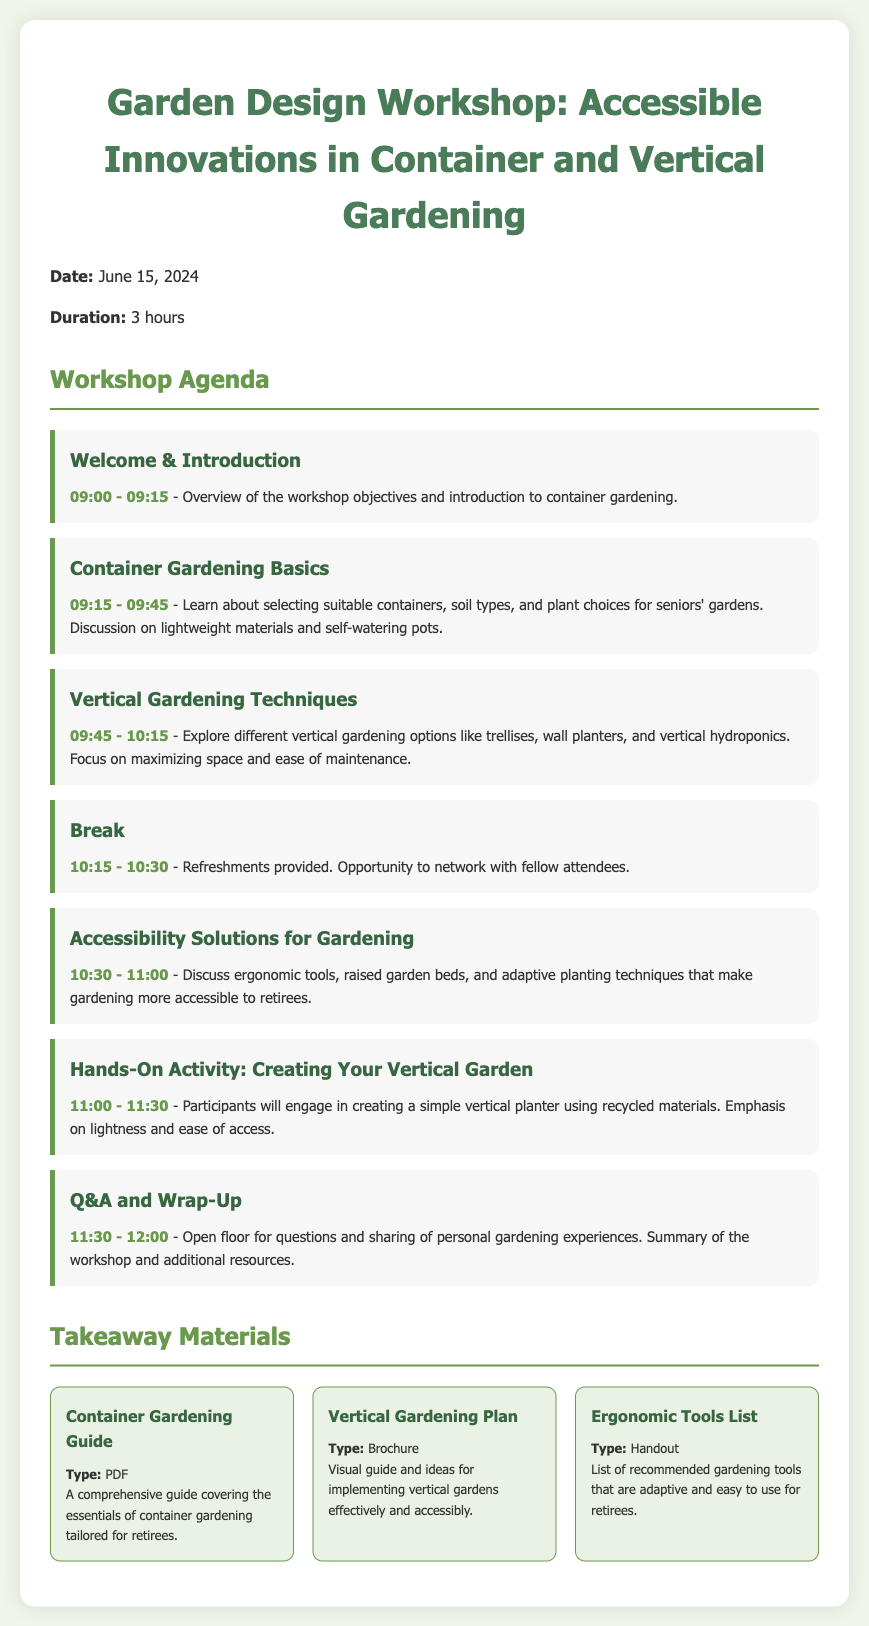What is the date of the workshop? The date of the workshop is stated directly in the document.
Answer: June 15, 2024 What time does the workshop start? The starting time is provided in the agenda section of the document.
Answer: 09:00 How long is the duration of the workshop? The duration is explicitly mentioned in the document.
Answer: 3 hours What is the focus of the 'Accessibility Solutions for Gardening' session? This session discusses various ways to make gardening more accessible, which is specified in the agenda.
Answer: Ergonomic tools, raised garden beds, and adaptive planting techniques What are participants creating in the hands-on activity? This detail is mentioned in the description of the hands-on activity within the agenda.
Answer: A simple vertical planter Which material type is the 'Container Gardening Guide'? The type of material for the Container Gardening Guide is provided in the takeaway materials section.
Answer: PDF What is one of the topics covered in the 'Container Gardening Basics' section? The specific topics in this section are described directly in the agenda.
Answer: Lightweight materials What is the purpose of the break? The purpose is mentioned in the agenda and gives an opportunity for interaction.
Answer: Refreshments and networking Which item emphasizes lightness and ease of access in the hands-on activity? This detail can be inferred from the description of the activity in the document.
Answer: Vertical planter 